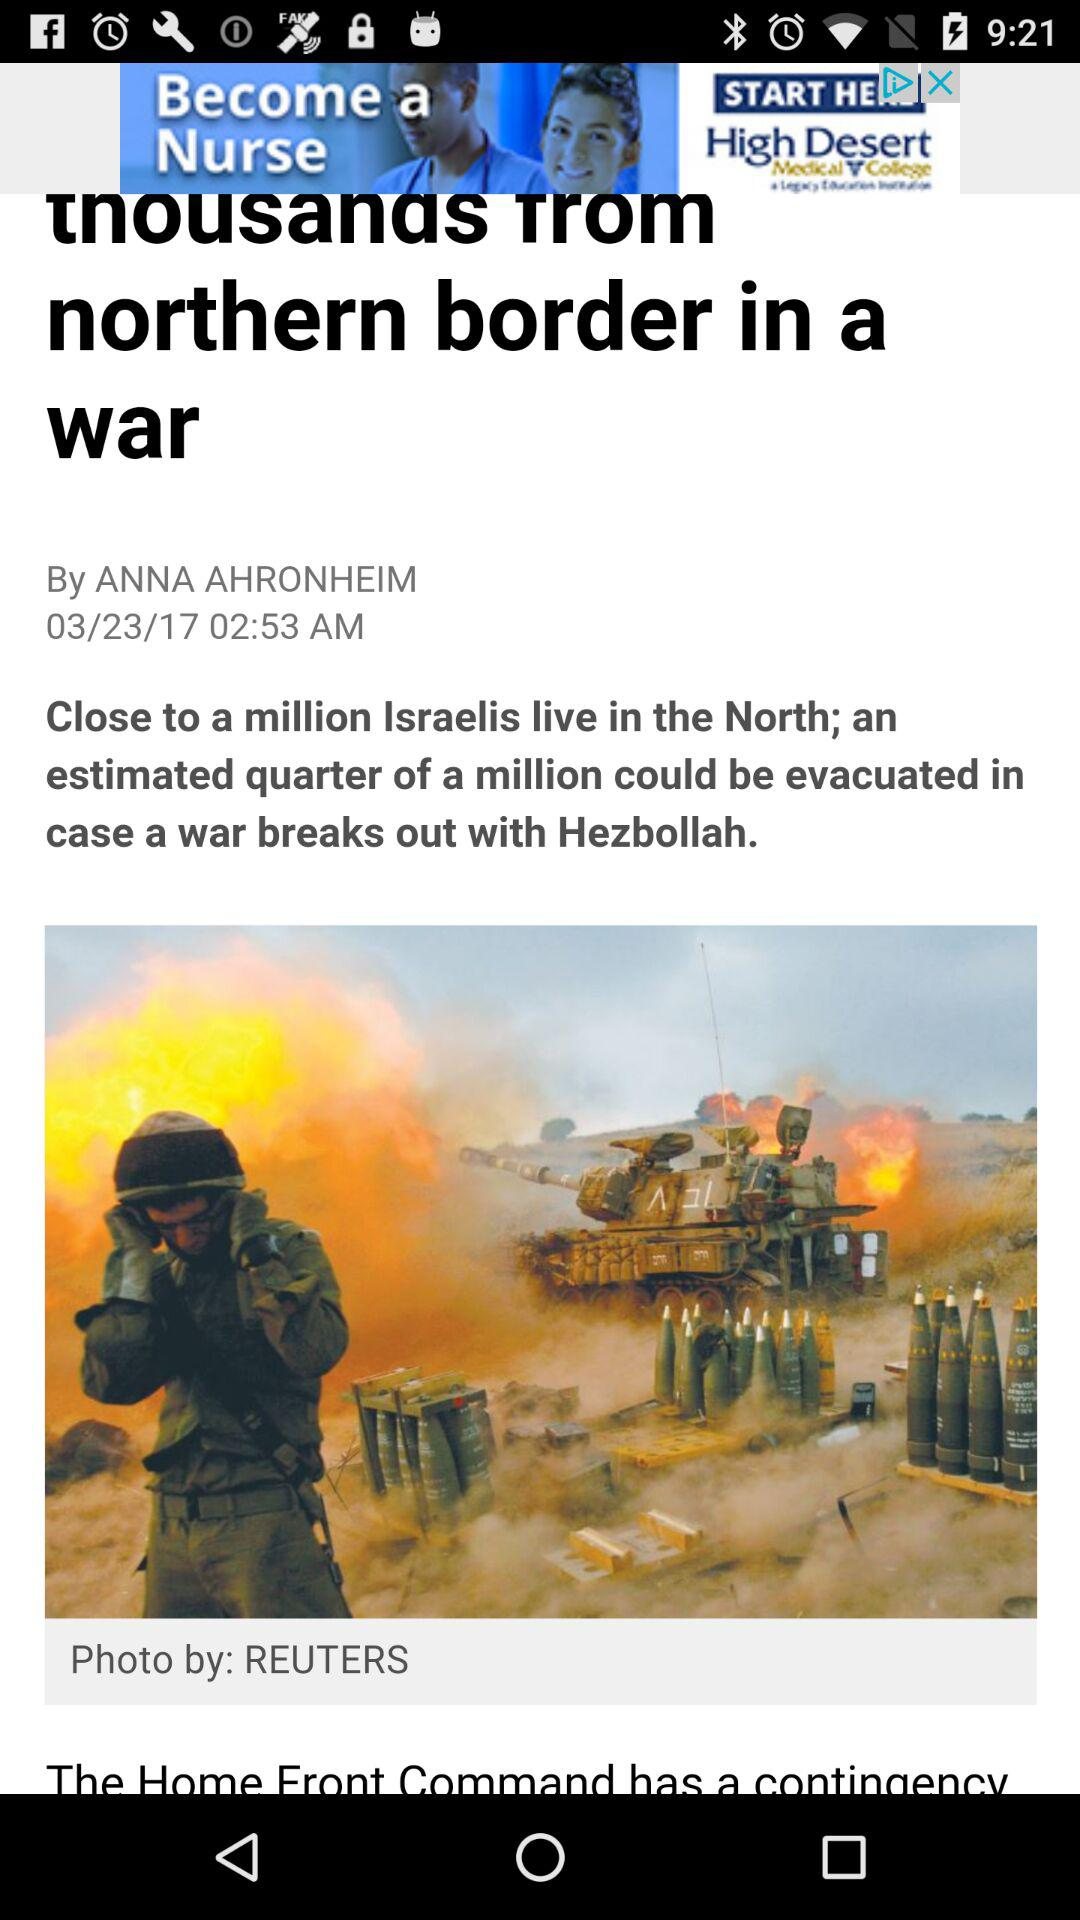What is the date on which the article was published? The date is March 23, 2017. 